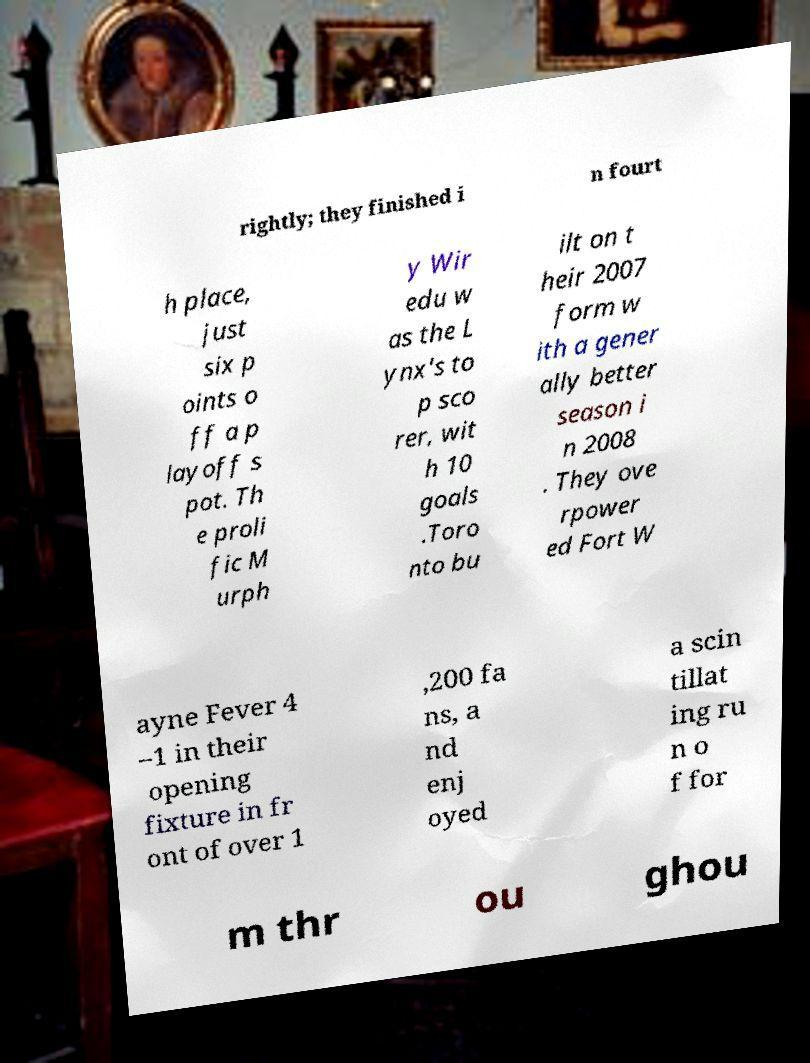For documentation purposes, I need the text within this image transcribed. Could you provide that? rightly; they finished i n fourt h place, just six p oints o ff a p layoff s pot. Th e proli fic M urph y Wir edu w as the L ynx's to p sco rer, wit h 10 goals .Toro nto bu ilt on t heir 2007 form w ith a gener ally better season i n 2008 . They ove rpower ed Fort W ayne Fever 4 –1 in their opening fixture in fr ont of over 1 ,200 fa ns, a nd enj oyed a scin tillat ing ru n o f for m thr ou ghou 